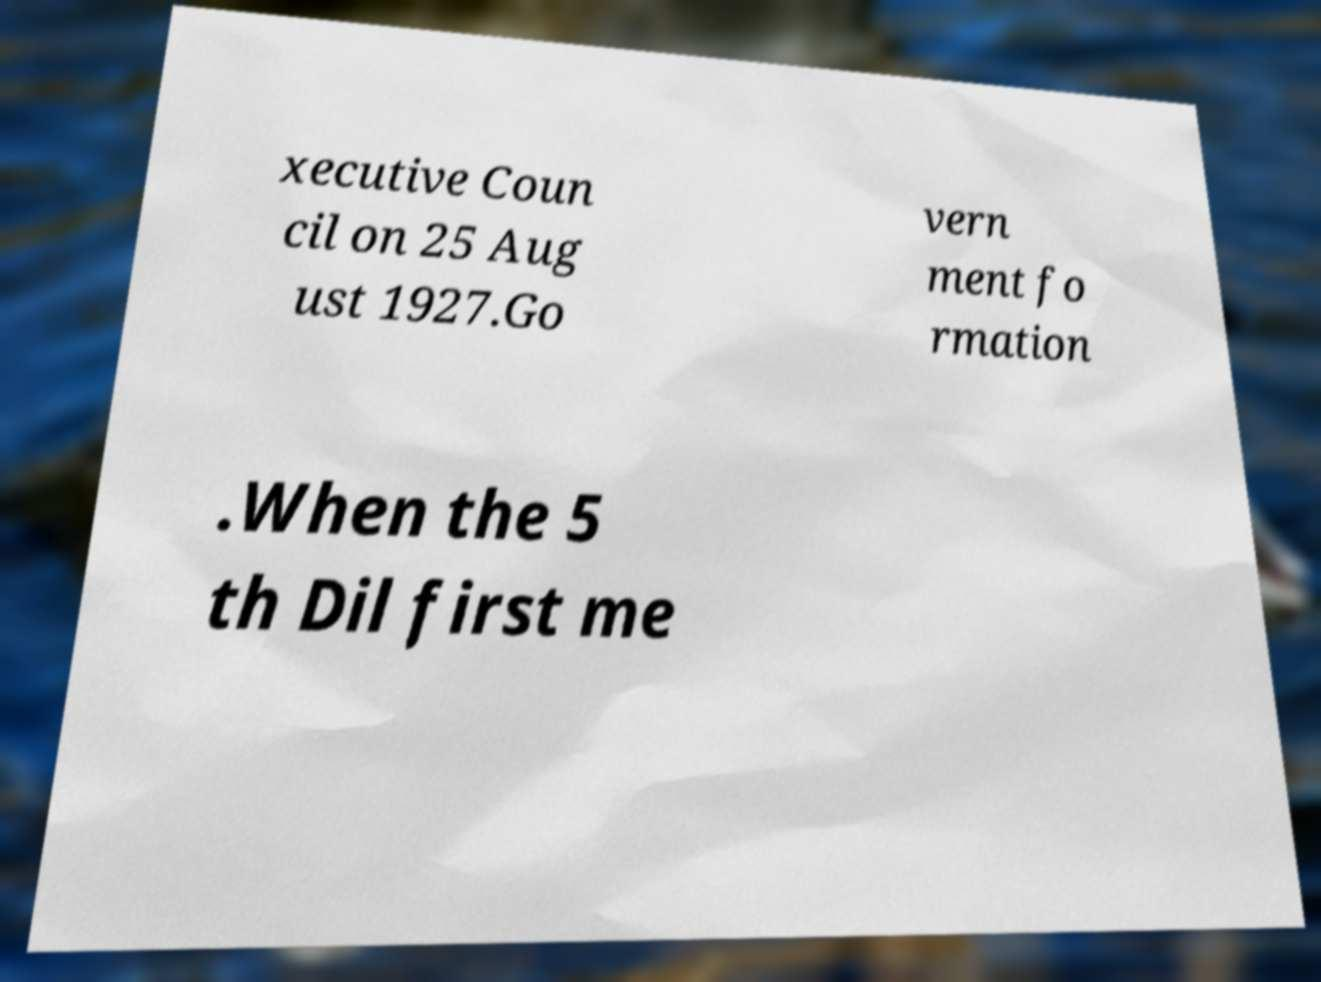Could you assist in decoding the text presented in this image and type it out clearly? xecutive Coun cil on 25 Aug ust 1927.Go vern ment fo rmation .When the 5 th Dil first me 